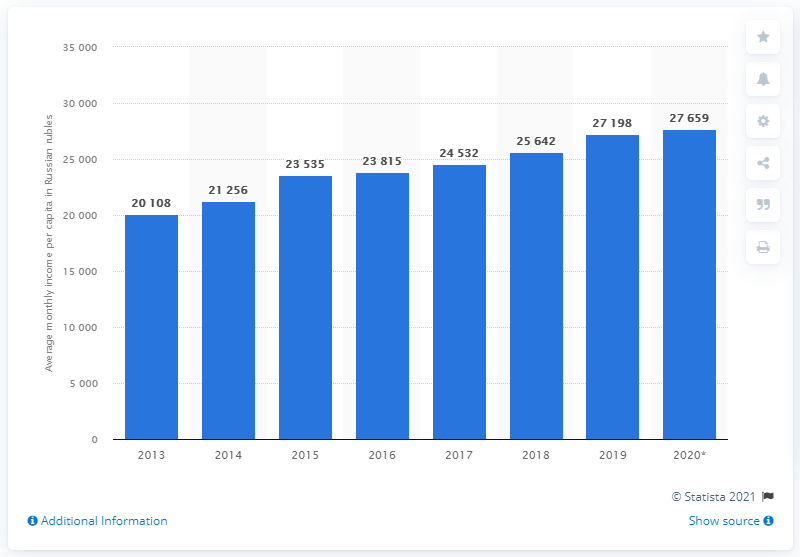Highlight a few significant elements in this photo. In 2020, the average monthly income per capita in the Siberian Federal District of Russia was 27,659 rubles. Between 2014 and 2015, the Siberian Federal District earned a total of 27,659 Russian rubles per month. 